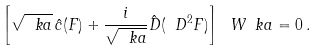<formula> <loc_0><loc_0><loc_500><loc_500>\left [ \sqrt { \ k a } \, \hat { c } ( F ) + \frac { i } { \sqrt { \ k a } } \hat { D } ( \ D ^ { 2 } F ) \right ] \ W _ { \ } k a = 0 \, .</formula> 